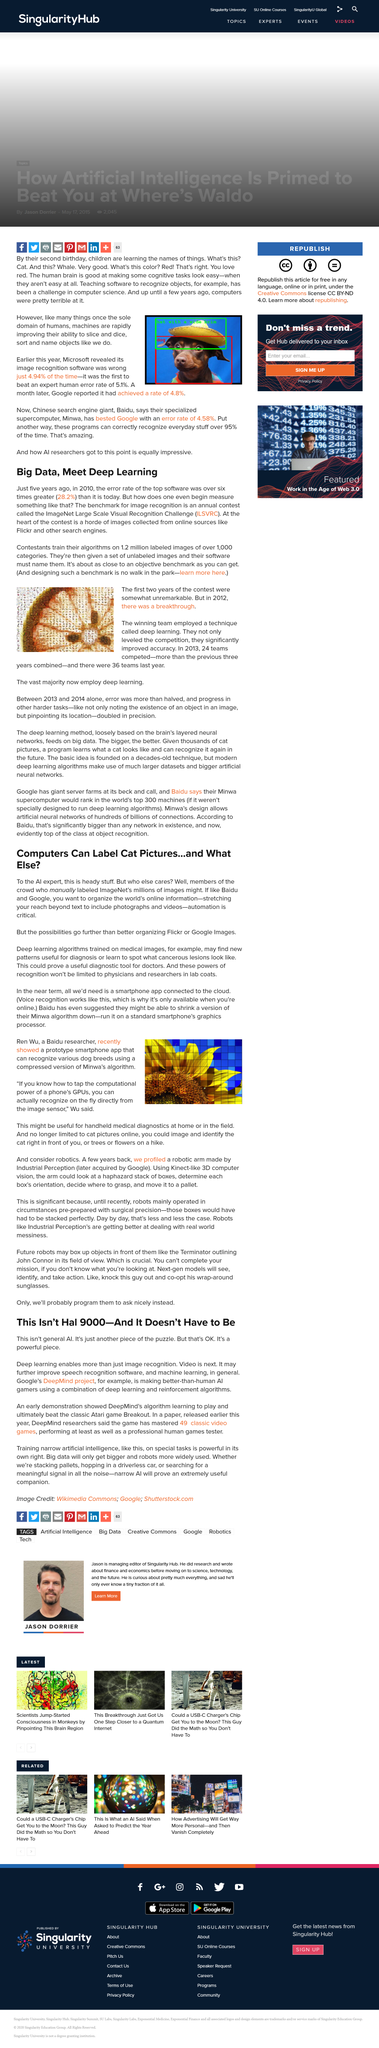Indicate a few pertinent items in this graphic. Our app is useful for handheld medical diagnostics and can be utilized at home or in the field. The acronym "ILSVRC" represents the ImageNet Large Scale Visual Recognition Challenge, which is a biennial competition organized by the Computer Vision Laboratory at the Cornell University to evaluate the state-of-the-art in image classification. The competition has become a benchmark for image recognition tasks and has resulted in the creation of several popular image classification datasets, including ImageNet. AI gamers rely on a combination of deep learning and reinforcement algorithms to achieve superior gaming performance. The use of deep learning algorithms trained on medical images may aid in the detection of new patterns for diagnosis purposes. Four weeks later, Google reported a 4.8% increase in profits. 